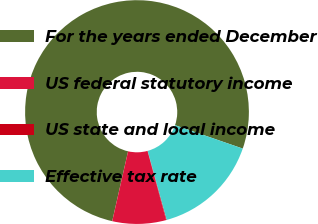<chart> <loc_0><loc_0><loc_500><loc_500><pie_chart><fcel>For the years ended December<fcel>US federal statutory income<fcel>US state and local income<fcel>Effective tax rate<nl><fcel>76.74%<fcel>7.75%<fcel>0.09%<fcel>15.42%<nl></chart> 